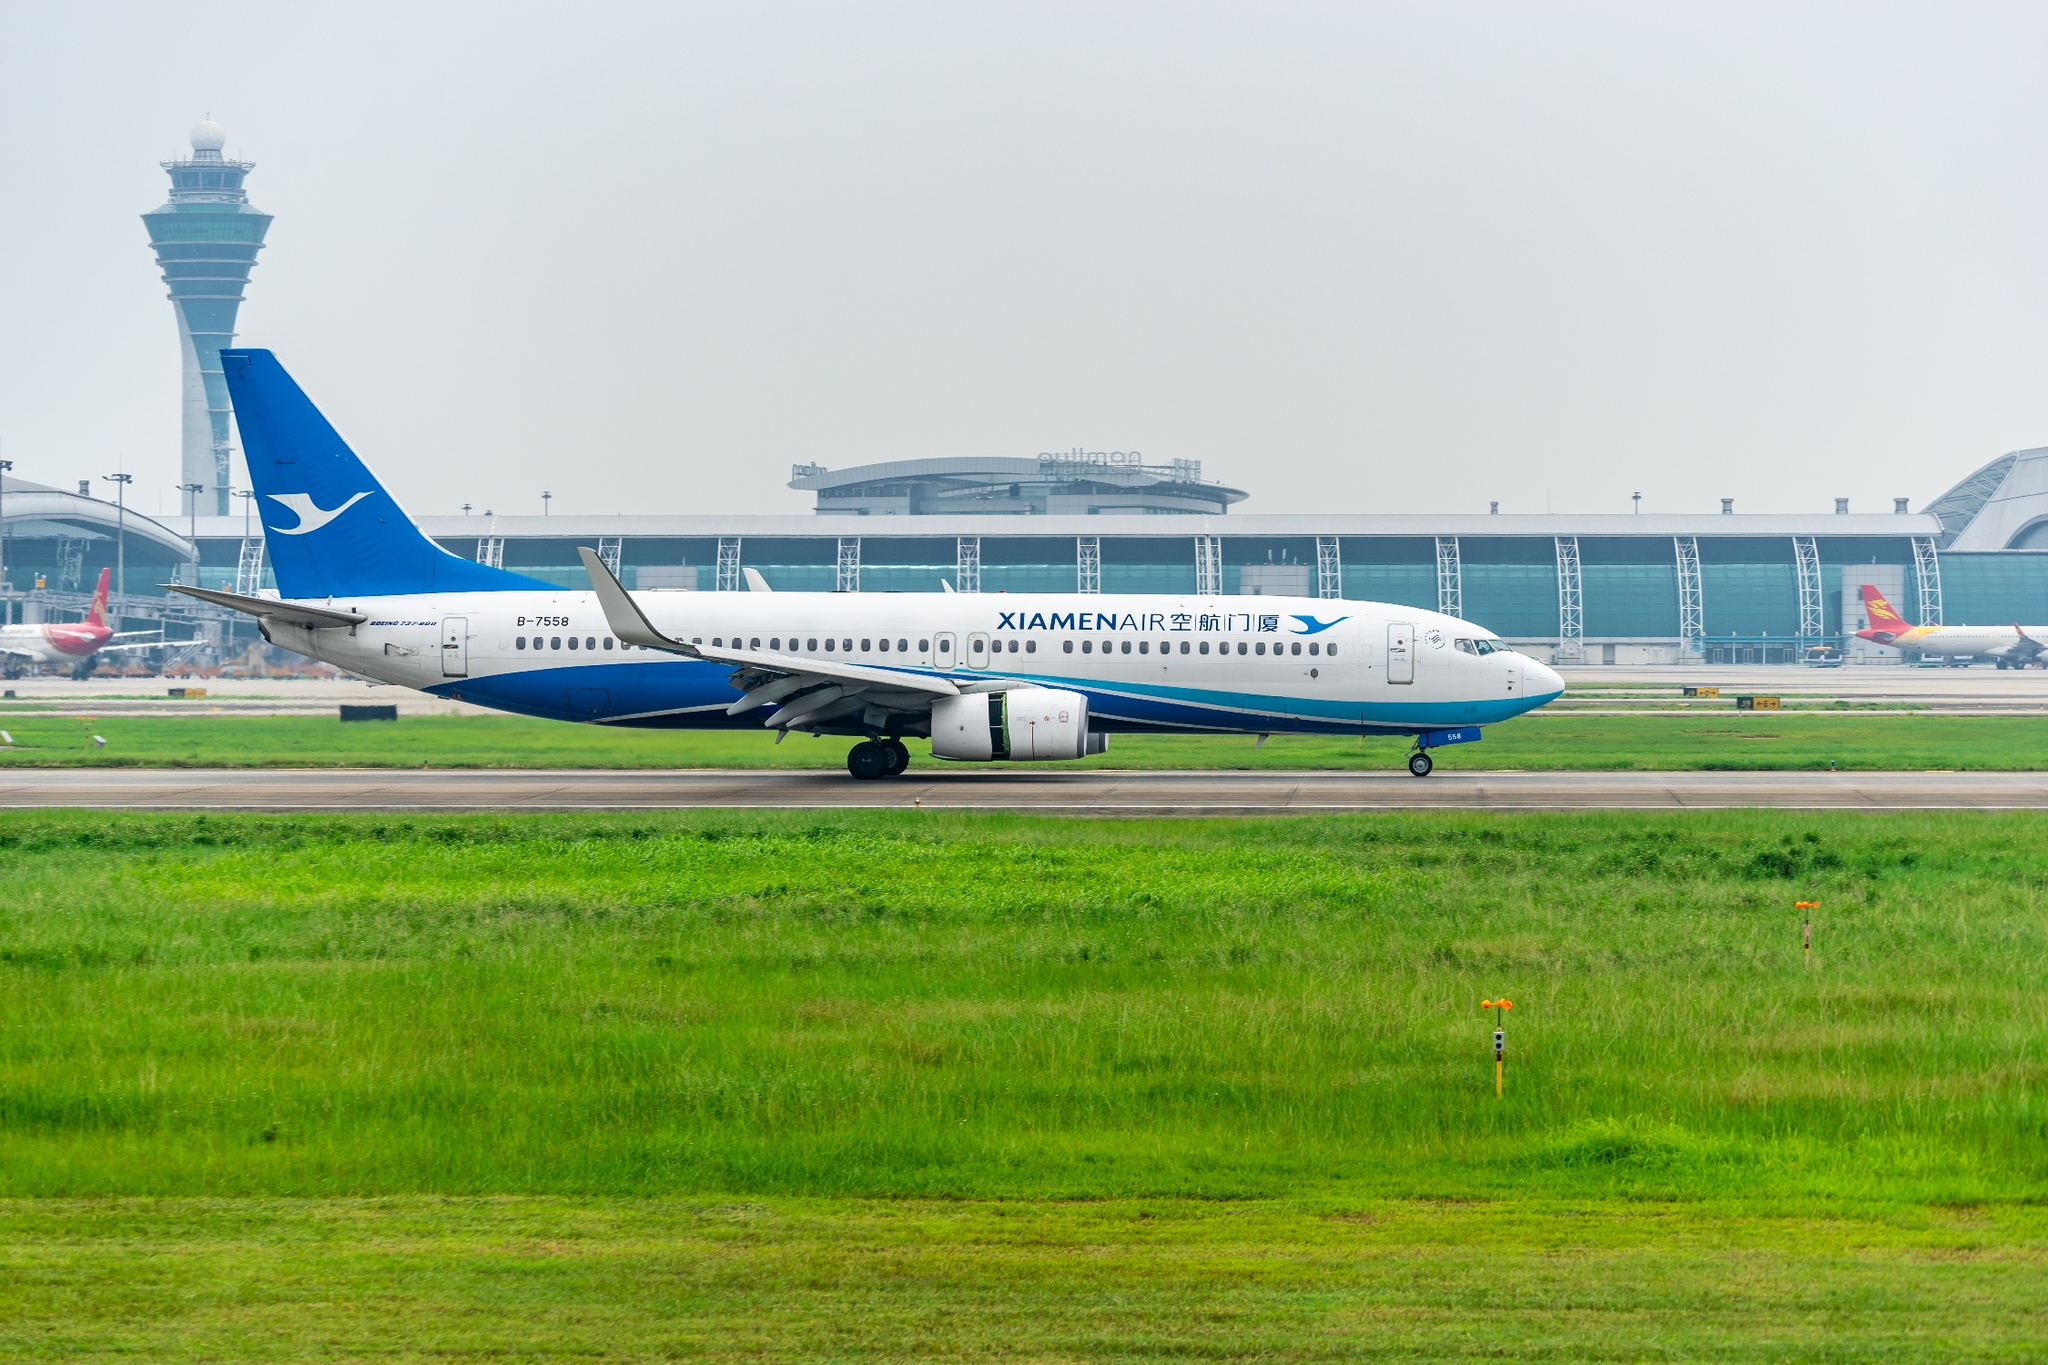Imagine if the airplane could talk. What might it say about its experience and surroundings? If the airplane could talk, it might share tales of the many destinations it has visited, describing the different landscapes and weather conditions it has encountered. It could talk about the diverse passengers it has carried, from excited tourists to business travelers. Reflecting on its current surroundings, it might express pride in representing XiamenAir and being part of the bustling airport environment, remarking on the professionalism of the ground crew that services it and the anticipation of its next journey. What's the longest flight this type of airplane can undertake and what are some typical routes for XiamenAir? The Boeing 737-800, which is the model represented in the image, can typically undertake flights up to approximately 3,500 nautical miles, depending on the specific configuration and conditions. For XiamenAir, typical routes might include domestic flights within China such as between Xiamen and Beijing, Shanghai, or Guangzhou. Internationally, it could service routes to nearby countries like Japan, South Korea, Thailand, and parts of Southeast Asia, facilitating both business and leisure travel to these destinations. 